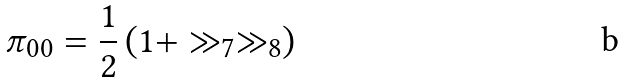Convert formula to latex. <formula><loc_0><loc_0><loc_500><loc_500>\pi _ { 0 0 } = \frac { 1 } { 2 } \left ( 1 + \gg _ { 7 } \gg _ { 8 } \right )</formula> 